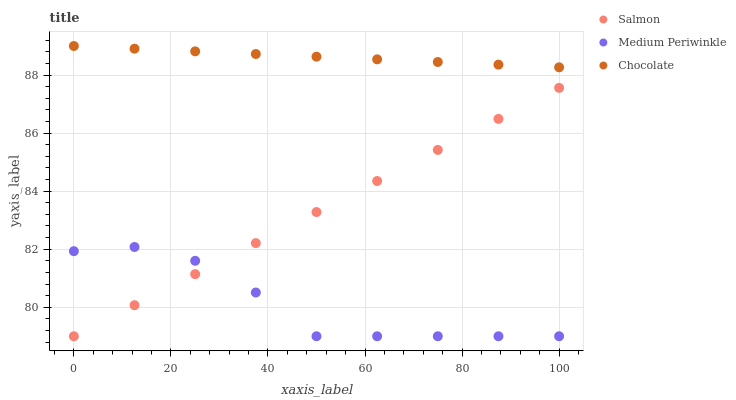Does Medium Periwinkle have the minimum area under the curve?
Answer yes or no. Yes. Does Chocolate have the maximum area under the curve?
Answer yes or no. Yes. Does Salmon have the minimum area under the curve?
Answer yes or no. No. Does Salmon have the maximum area under the curve?
Answer yes or no. No. Is Chocolate the smoothest?
Answer yes or no. Yes. Is Medium Periwinkle the roughest?
Answer yes or no. Yes. Is Salmon the smoothest?
Answer yes or no. No. Is Salmon the roughest?
Answer yes or no. No. Does Medium Periwinkle have the lowest value?
Answer yes or no. Yes. Does Chocolate have the lowest value?
Answer yes or no. No. Does Chocolate have the highest value?
Answer yes or no. Yes. Does Salmon have the highest value?
Answer yes or no. No. Is Medium Periwinkle less than Chocolate?
Answer yes or no. Yes. Is Chocolate greater than Medium Periwinkle?
Answer yes or no. Yes. Does Salmon intersect Medium Periwinkle?
Answer yes or no. Yes. Is Salmon less than Medium Periwinkle?
Answer yes or no. No. Is Salmon greater than Medium Periwinkle?
Answer yes or no. No. Does Medium Periwinkle intersect Chocolate?
Answer yes or no. No. 